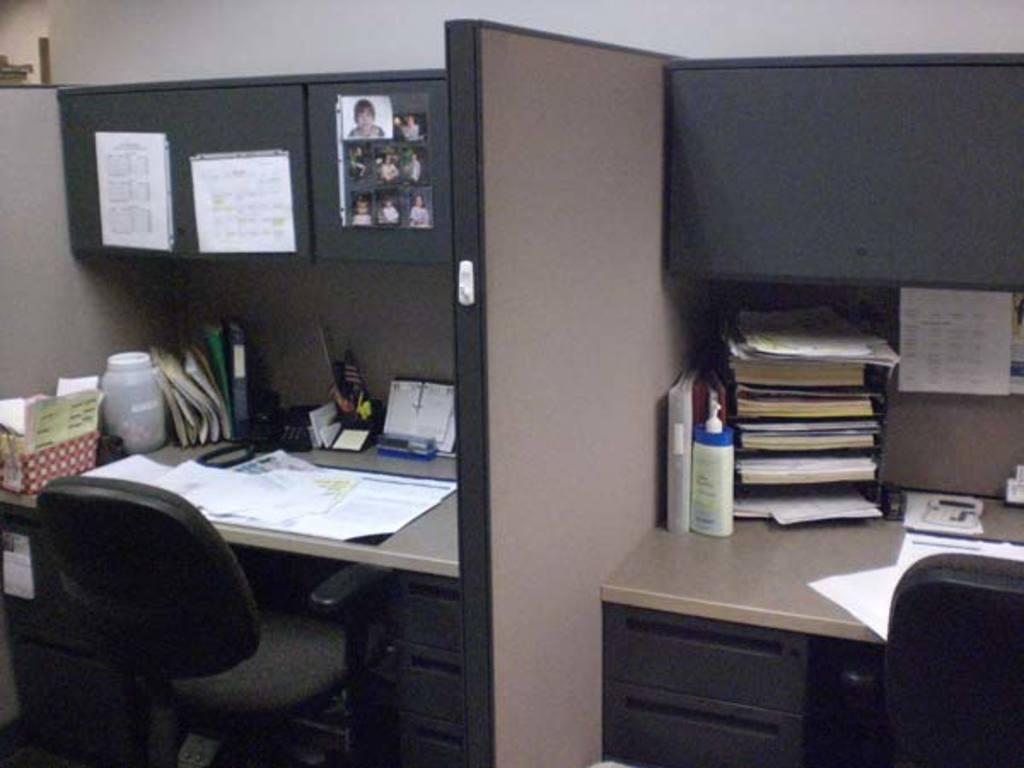Can you describe this image briefly? In this picture we can see two tables with desk and some things like files, pens, telephone and some papers and some pictures and and papers to the note on the desk. 